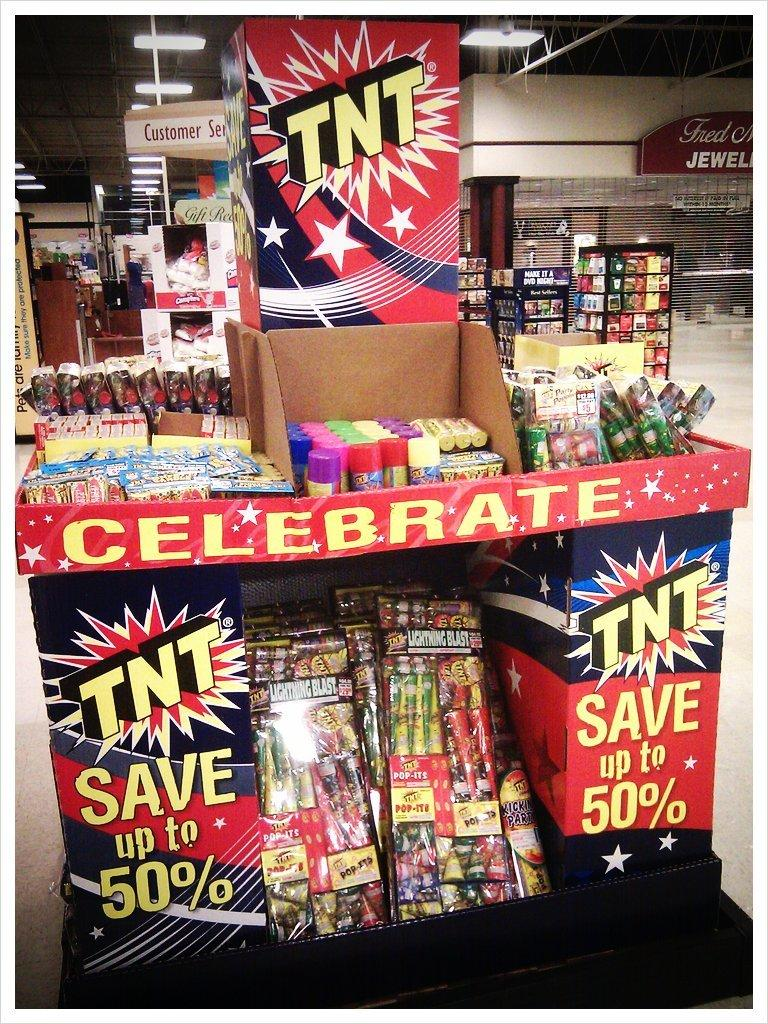<image>
Summarize the visual content of the image. Save up to 50% of TNT fireworks is displayed with other fireworks. 